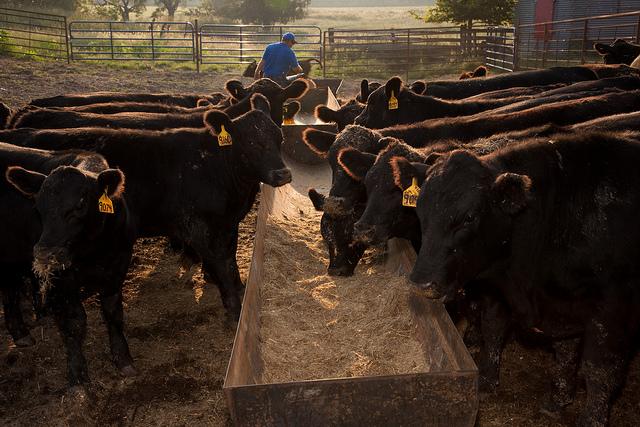What is the man doing in the picture?
Be succinct. Feeding cows. What are the noses on the animals called?
Answer briefly. Snout. Is this in a rural area?
Concise answer only. Yes. Do the cows look content?
Concise answer only. Yes. Is this a brown cow?
Concise answer only. Yes. What sort of food are the cows eating?
Give a very brief answer. Grain. What are the animals eating?
Write a very short answer. Grain. What country is this?
Quick response, please. United states. Is there fresh grass for the cows to eat?
Short answer required. No. Is this a farm?
Keep it brief. Yes. 